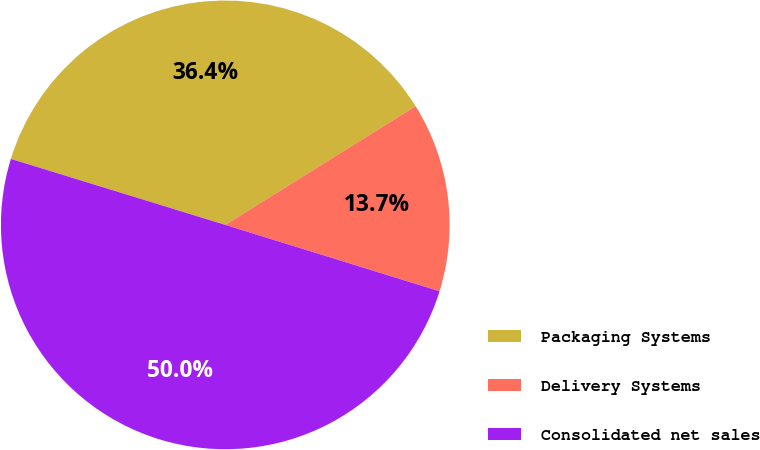Convert chart. <chart><loc_0><loc_0><loc_500><loc_500><pie_chart><fcel>Packaging Systems<fcel>Delivery Systems<fcel>Consolidated net sales<nl><fcel>36.37%<fcel>13.66%<fcel>49.97%<nl></chart> 